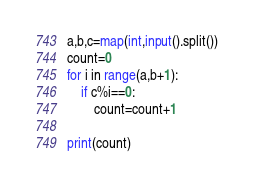<code> <loc_0><loc_0><loc_500><loc_500><_Python_>a,b,c=map(int,input().split())
count=0
for i in range(a,b+1):
    if c%i==0:
        count=count+1

print(count)
</code> 